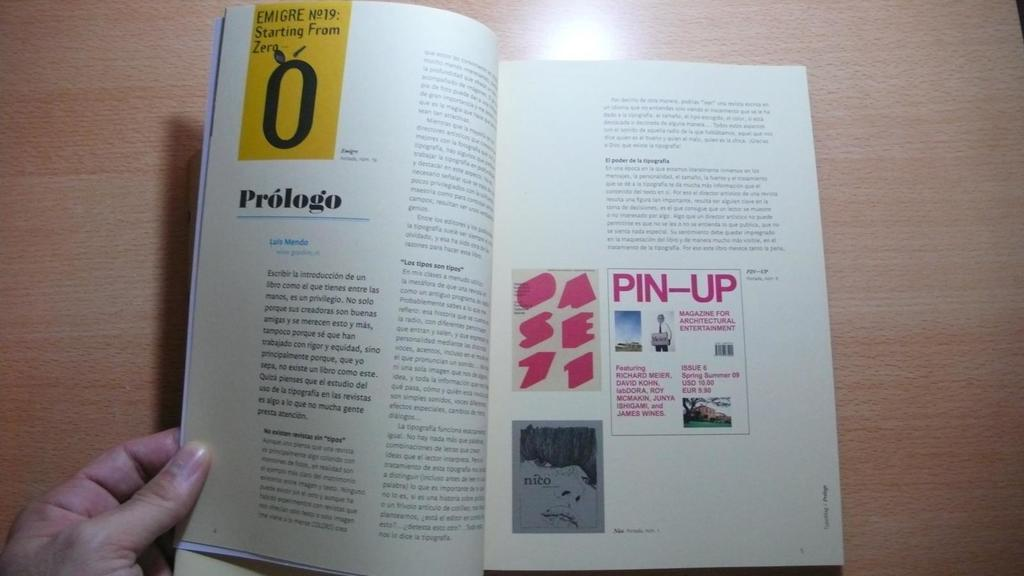Provide a one-sentence caption for the provided image. Open book about Prologo and Luis Mendo with a pin up sign. 